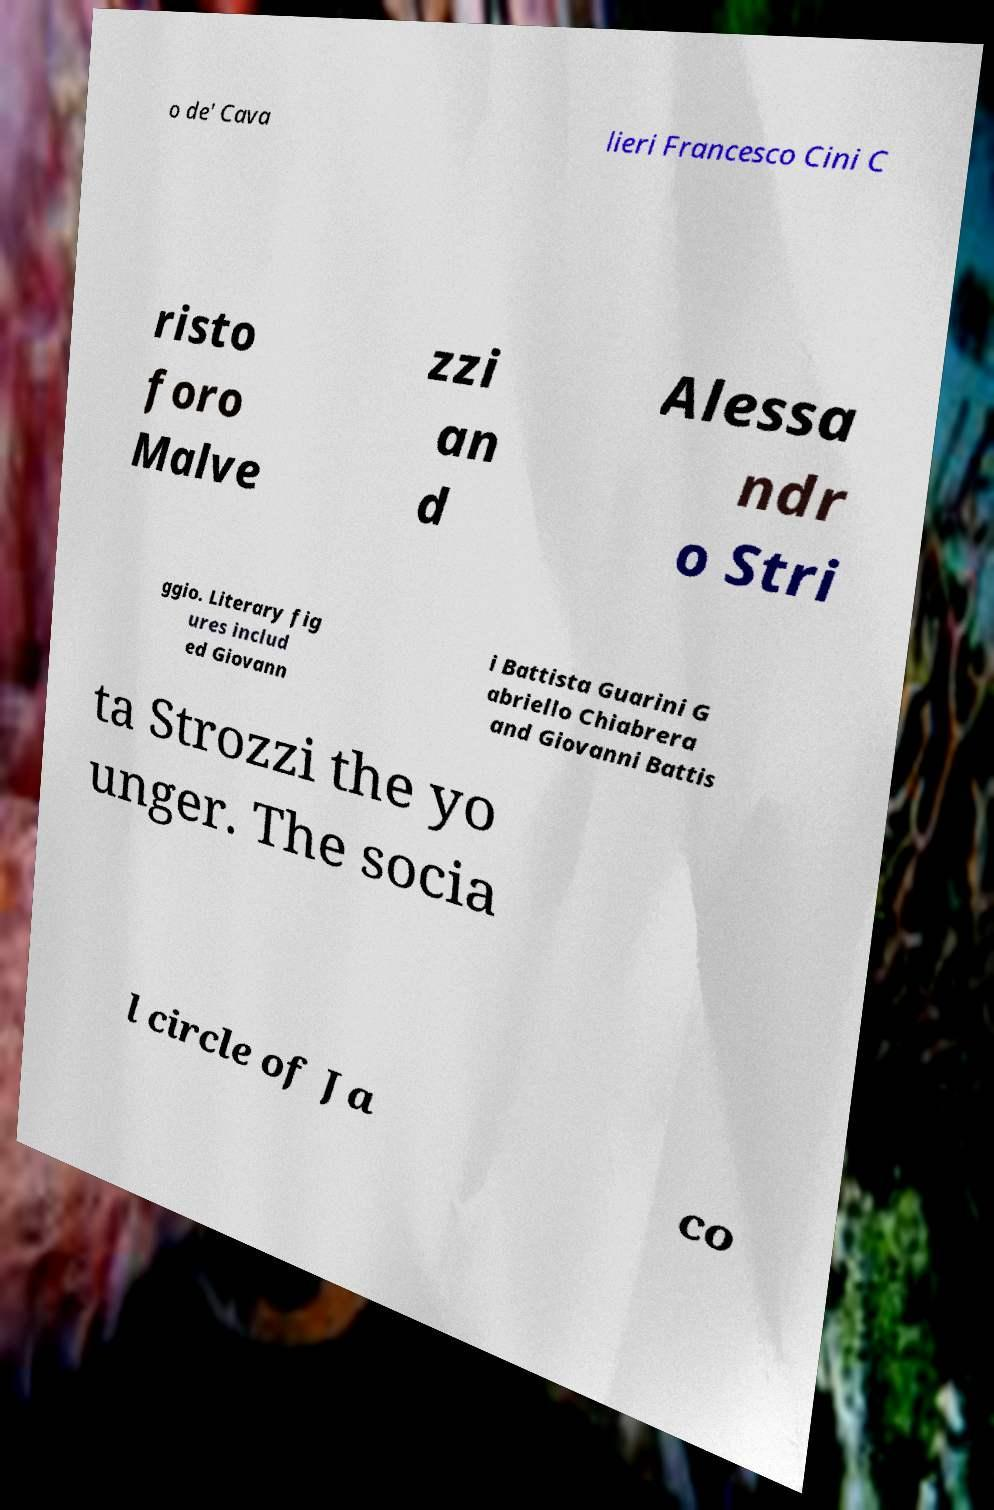Could you extract and type out the text from this image? o de' Cava lieri Francesco Cini C risto foro Malve zzi an d Alessa ndr o Stri ggio. Literary fig ures includ ed Giovann i Battista Guarini G abriello Chiabrera and Giovanni Battis ta Strozzi the yo unger. The socia l circle of Ja co 